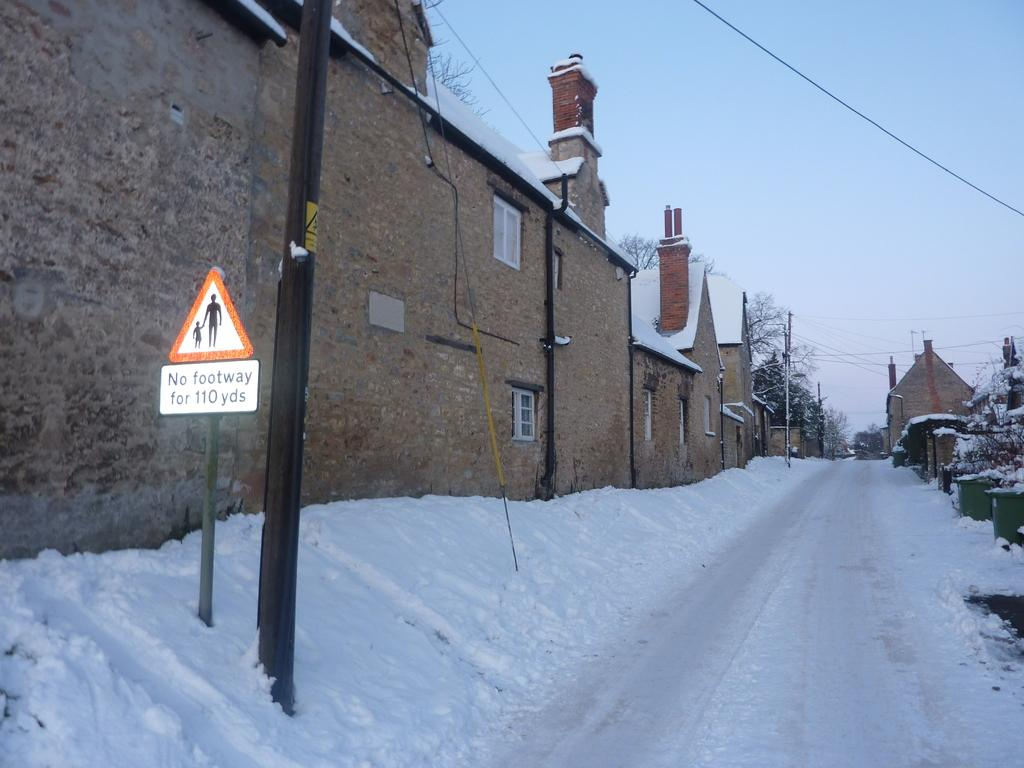What is the condition of the road in the image? The road is covered with snow in the image. What is located on the left side of the image? There is a wall on the left side of the image. What objects can be seen in the image that are used for supporting or guiding? There are poles in the image. What is present in the image that might display information or advertisements? There is a board in the image. What type of vegetation is visible in the background of the image? There are trees in the background of the image. What is visible in the sky in the background of the image? The sky is visible in the background of the image. How does the rain affect the snow on the road in the image? There is no rain present in the image; the road is covered with snow. What is in the middle of the wall in the image? There is no object or feature in the middle of the wall in the image; the wall is a solid structure. 